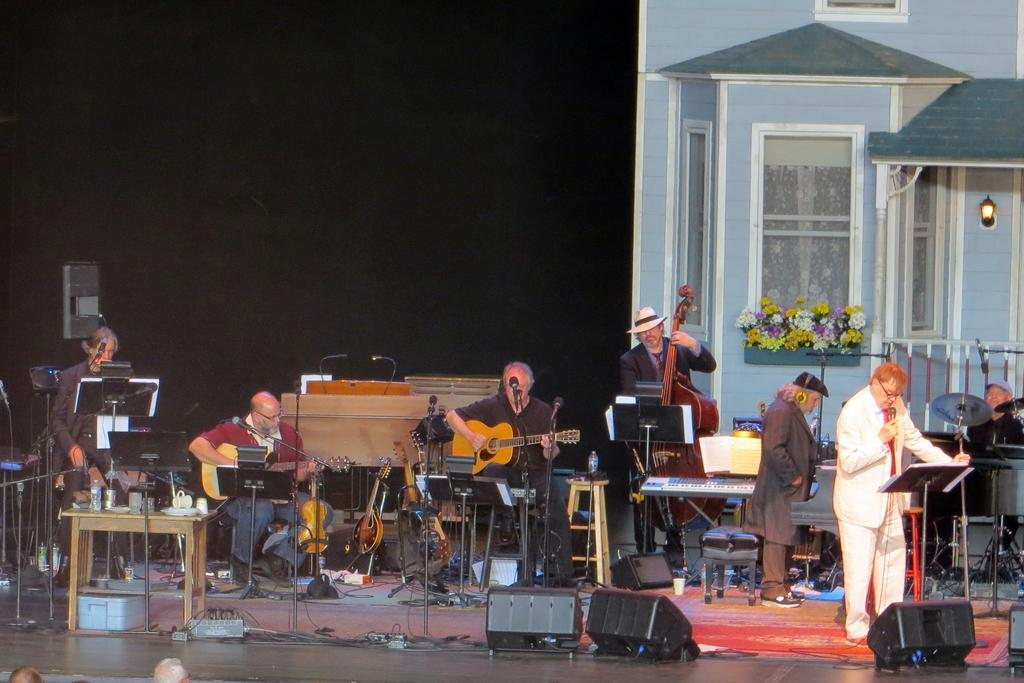What are the people in the image doing? The people in the image are playing musical instruments. Are there any vocalists in the group? Yes, two people are singing in front of a microphone. What type of tomatoes are being used as a prop in the image? There are no tomatoes present in the image. What letter is being used as a prop in the image? There is no letter being used as a prop in the image. 